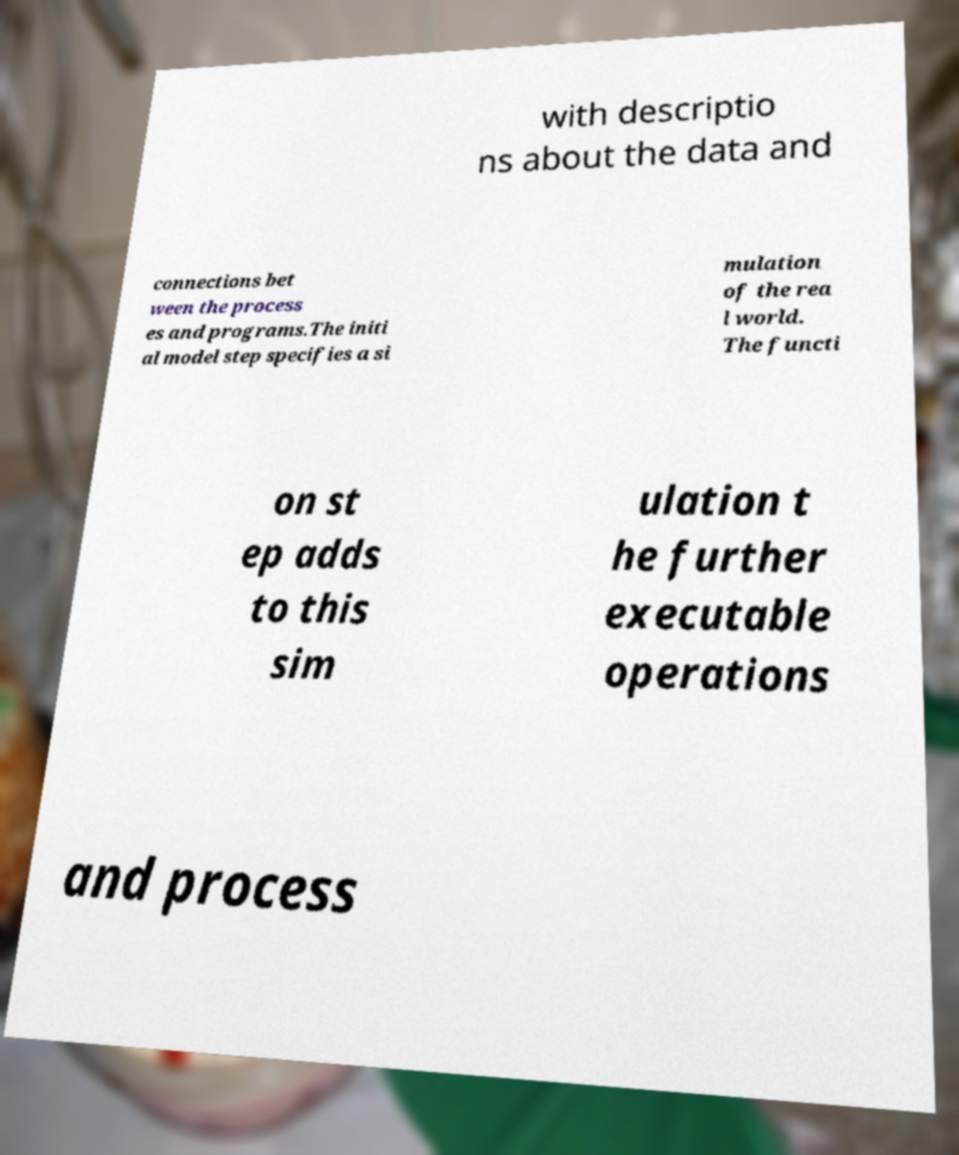I need the written content from this picture converted into text. Can you do that? with descriptio ns about the data and connections bet ween the process es and programs.The initi al model step specifies a si mulation of the rea l world. The functi on st ep adds to this sim ulation t he further executable operations and process 